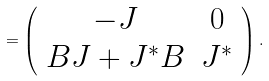<formula> <loc_0><loc_0><loc_500><loc_500>= \left ( \begin{array} { c c } - J & 0 \\ B J + J ^ { * } B & J ^ { * } \end{array} \right ) .</formula> 